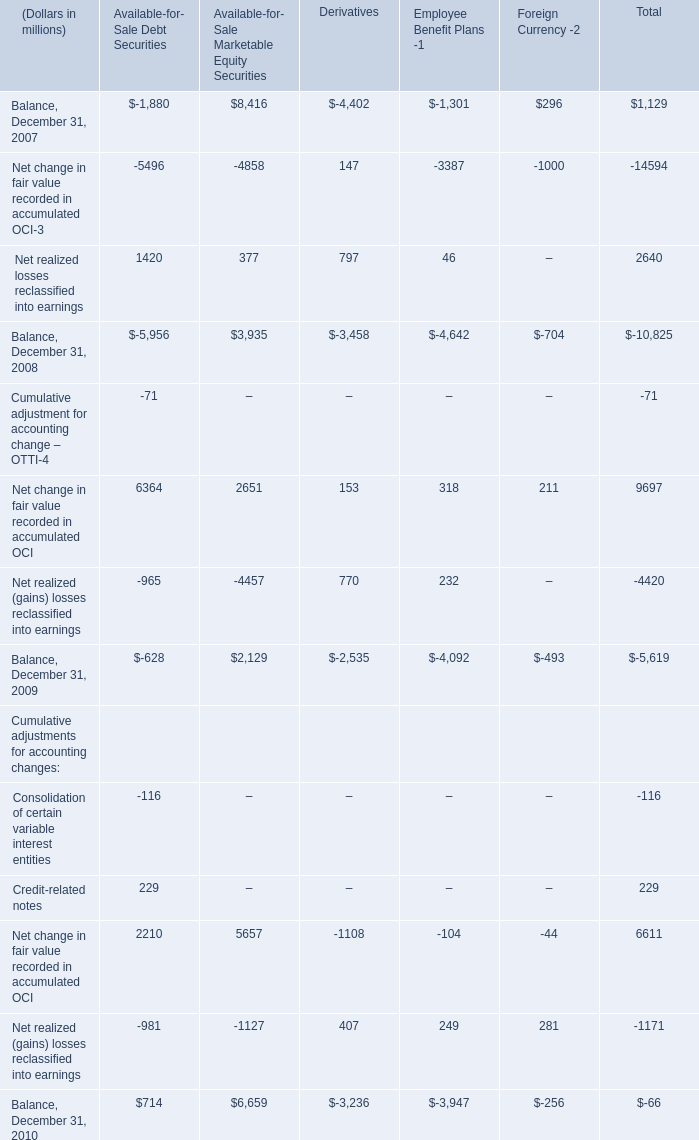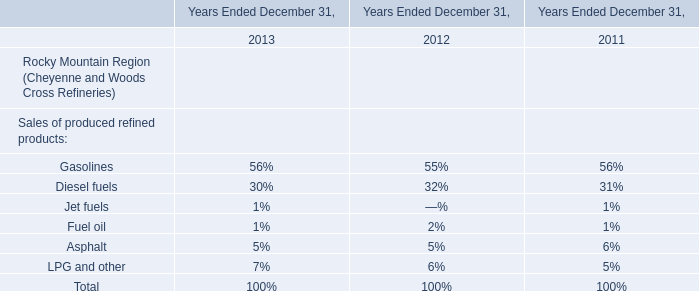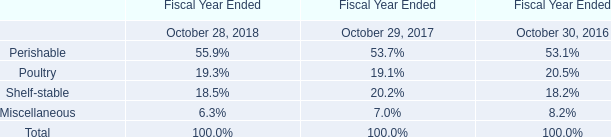What is the total value of Available-for- Sale Debt Securities, Available-for- Sale Marketable Equity Securities, Derivatives and Employee Benefit Plans -1 in Balance, December 31, 2007 ? (in million) 
Computations: (((-1880 + 8416) - 4402) - 1301)
Answer: 833.0. 